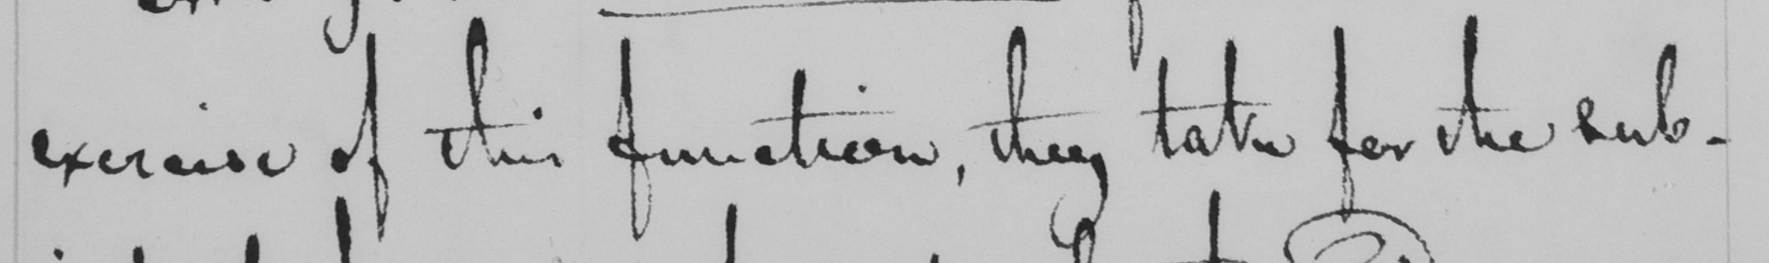What is written in this line of handwriting? exercise of this function , they take for the sub- 